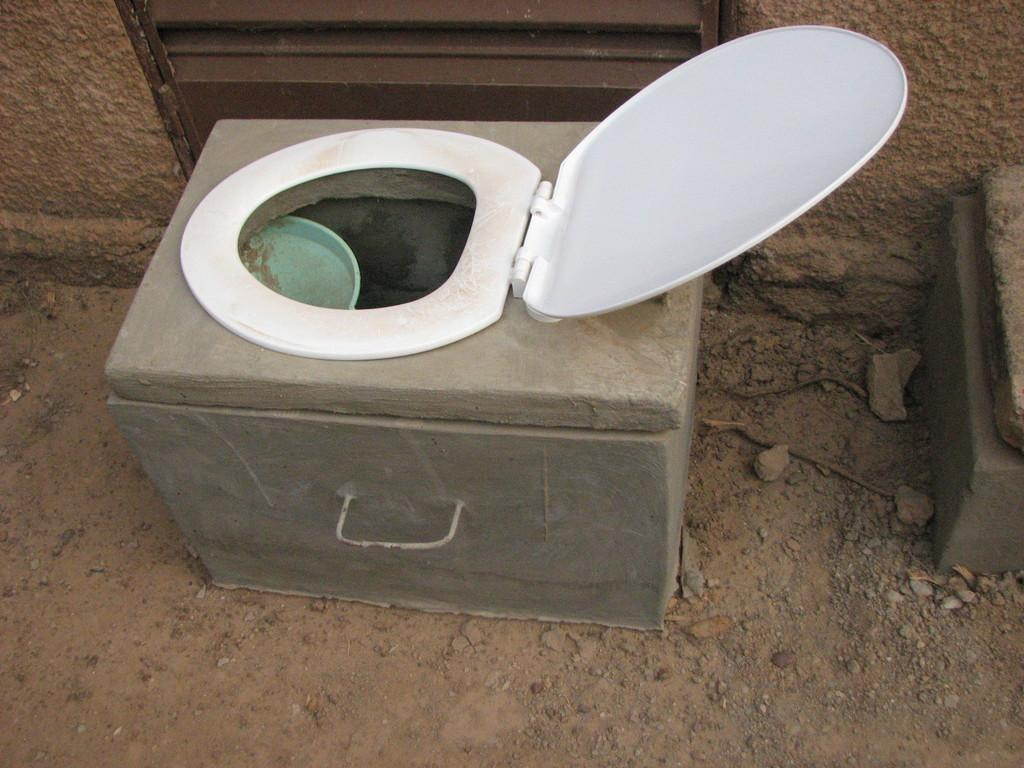What is the main object in the center of the image? There is a toilet seat in the center of the image. What type of surface is visible at the bottom of the image? There is sand at the bottom of the image. What can be seen in the background of the image? There is a wall in the background of the image. What type of powder is being used to grow the plants in the image? There are no plants present in the image, so there is no powder being used for plant growth. 